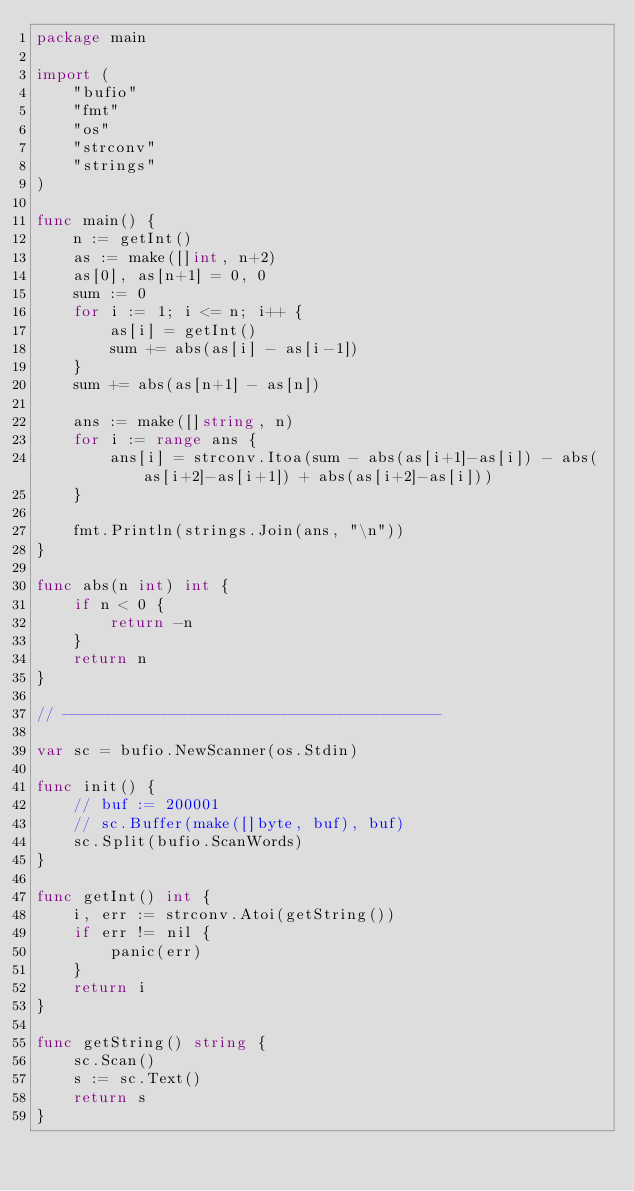Convert code to text. <code><loc_0><loc_0><loc_500><loc_500><_Go_>package main

import (
	"bufio"
	"fmt"
	"os"
	"strconv"
	"strings"
)

func main() {
	n := getInt()
	as := make([]int, n+2)
	as[0], as[n+1] = 0, 0
	sum := 0
	for i := 1; i <= n; i++ {
		as[i] = getInt()
		sum += abs(as[i] - as[i-1])
	}
	sum += abs(as[n+1] - as[n])

	ans := make([]string, n)
	for i := range ans {
		ans[i] = strconv.Itoa(sum - abs(as[i+1]-as[i]) - abs(as[i+2]-as[i+1]) + abs(as[i+2]-as[i]))
	}

	fmt.Println(strings.Join(ans, "\n"))
}

func abs(n int) int {
	if n < 0 {
		return -n
	}
	return n
}

// -----------------------------------------

var sc = bufio.NewScanner(os.Stdin)

func init() {
	// buf := 200001
	// sc.Buffer(make([]byte, buf), buf)
	sc.Split(bufio.ScanWords)
}

func getInt() int {
	i, err := strconv.Atoi(getString())
	if err != nil {
		panic(err)
	}
	return i
}

func getString() string {
	sc.Scan()
	s := sc.Text()
	return s
}
</code> 